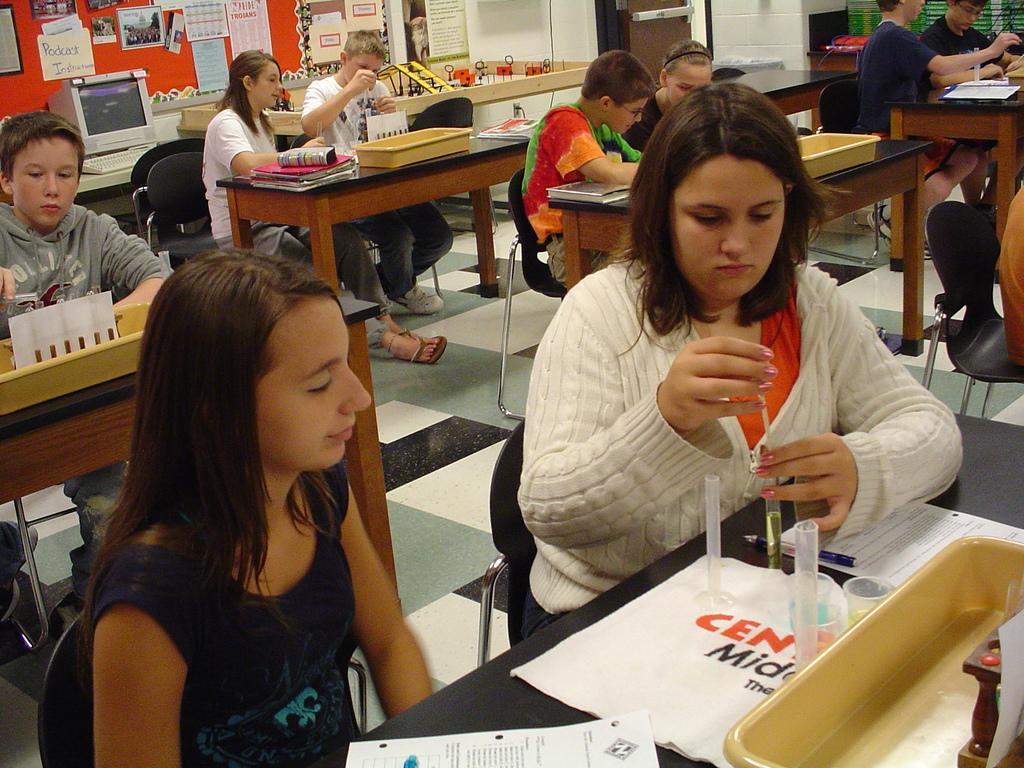How would you summarize this image in a sentence or two? In this image I can see number of people are sitting on chairs. I can also see stuffs on their tables. In the background I can see a monitor and a keyboard. 